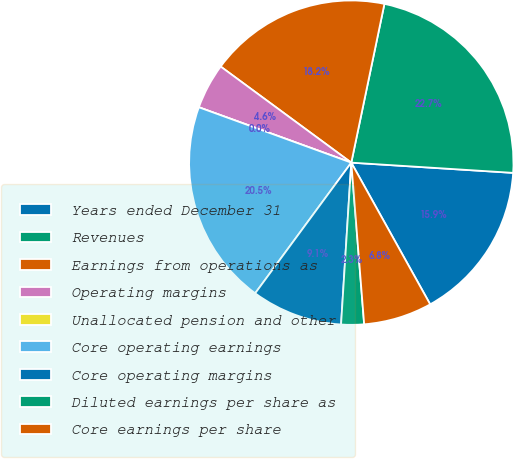Convert chart. <chart><loc_0><loc_0><loc_500><loc_500><pie_chart><fcel>Years ended December 31<fcel>Revenues<fcel>Earnings from operations as<fcel>Operating margins<fcel>Unallocated pension and other<fcel>Core operating earnings<fcel>Core operating margins<fcel>Diluted earnings per share as<fcel>Core earnings per share<nl><fcel>15.91%<fcel>22.73%<fcel>18.18%<fcel>4.55%<fcel>0.0%<fcel>20.45%<fcel>9.09%<fcel>2.27%<fcel>6.82%<nl></chart> 